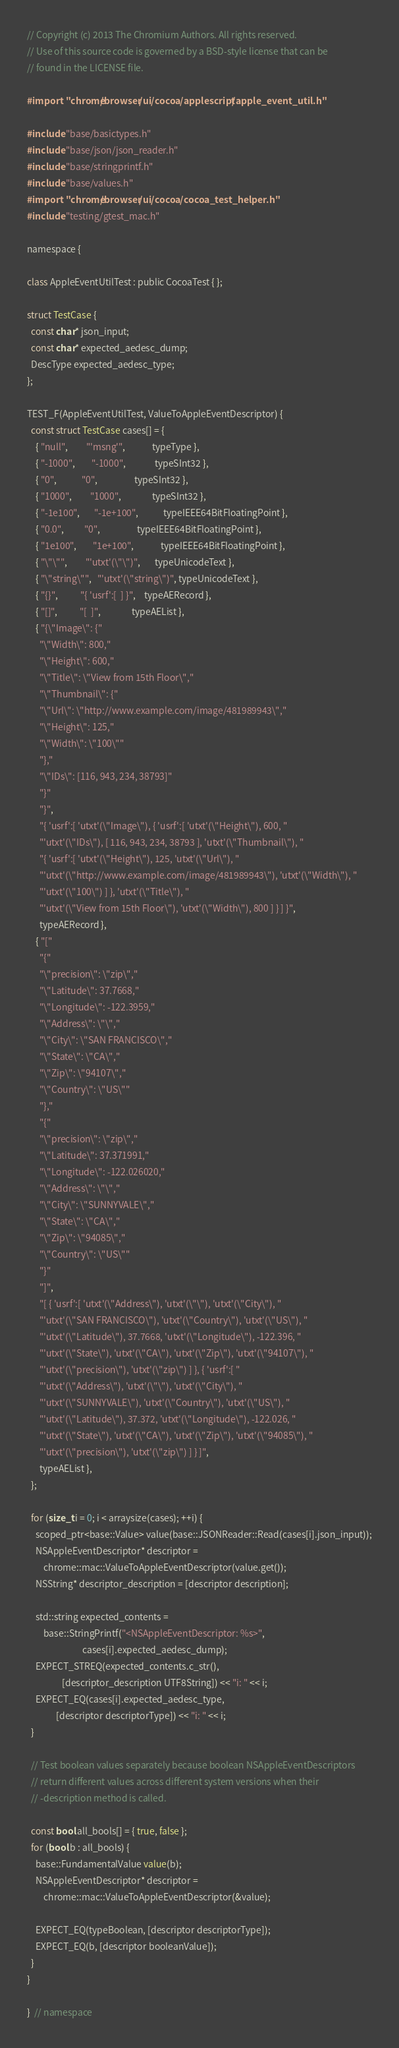<code> <loc_0><loc_0><loc_500><loc_500><_ObjectiveC_>// Copyright (c) 2013 The Chromium Authors. All rights reserved.
// Use of this source code is governed by a BSD-style license that can be
// found in the LICENSE file.

#import "chrome/browser/ui/cocoa/applescript/apple_event_util.h"

#include "base/basictypes.h"
#include "base/json/json_reader.h"
#include "base/stringprintf.h"
#include "base/values.h"
#import "chrome/browser/ui/cocoa/cocoa_test_helper.h"
#include "testing/gtest_mac.h"

namespace {

class AppleEventUtilTest : public CocoaTest { };

struct TestCase {
  const char* json_input;
  const char* expected_aedesc_dump;
  DescType expected_aedesc_type;
};

TEST_F(AppleEventUtilTest, ValueToAppleEventDescriptor) {
  const struct TestCase cases[] = {
    { "null",         "'msng'",             typeType },
    { "-1000",        "-1000",              typeSInt32 },
    { "0",            "0",                  typeSInt32 },
    { "1000",         "1000",               typeSInt32 },
    { "-1e100",       "-1e+100",            typeIEEE64BitFloatingPoint },
    { "0.0",          "0",                  typeIEEE64BitFloatingPoint },
    { "1e100",        "1e+100",             typeIEEE64BitFloatingPoint },
    { "\"\"",         "'utxt'(\"\")",       typeUnicodeText },
    { "\"string\"",   "'utxt'(\"string\")", typeUnicodeText },
    { "{}",           "{ 'usrf':[  ] }",    typeAERecord },
    { "[]",           "[  ]",               typeAEList },
    { "{\"Image\": {"
      "\"Width\": 800,"
      "\"Height\": 600,"
      "\"Title\": \"View from 15th Floor\","
      "\"Thumbnail\": {"
      "\"Url\": \"http://www.example.com/image/481989943\","
      "\"Height\": 125,"
      "\"Width\": \"100\""
      "},"
      "\"IDs\": [116, 943, 234, 38793]"
      "}"
      "}",
      "{ 'usrf':[ 'utxt'(\"Image\"), { 'usrf':[ 'utxt'(\"Height\"), 600, "
      "'utxt'(\"IDs\"), [ 116, 943, 234, 38793 ], 'utxt'(\"Thumbnail\"), "
      "{ 'usrf':[ 'utxt'(\"Height\"), 125, 'utxt'(\"Url\"), "
      "'utxt'(\"http://www.example.com/image/481989943\"), 'utxt'(\"Width\"), "
      "'utxt'(\"100\") ] }, 'utxt'(\"Title\"), "
      "'utxt'(\"View from 15th Floor\"), 'utxt'(\"Width\"), 800 ] } ] }",
      typeAERecord },
    { "["
      "{"
      "\"precision\": \"zip\","
      "\"Latitude\": 37.7668,"
      "\"Longitude\": -122.3959,"
      "\"Address\": \"\","
      "\"City\": \"SAN FRANCISCO\","
      "\"State\": \"CA\","
      "\"Zip\": \"94107\","
      "\"Country\": \"US\""
      "},"
      "{"
      "\"precision\": \"zip\","
      "\"Latitude\": 37.371991,"
      "\"Longitude\": -122.026020,"
      "\"Address\": \"\","
      "\"City\": \"SUNNYVALE\","
      "\"State\": \"CA\","
      "\"Zip\": \"94085\","
      "\"Country\": \"US\""
      "}"
      "]",
      "[ { 'usrf':[ 'utxt'(\"Address\"), 'utxt'(\"\"), 'utxt'(\"City\"), "
      "'utxt'(\"SAN FRANCISCO\"), 'utxt'(\"Country\"), 'utxt'(\"US\"), "
      "'utxt'(\"Latitude\"), 37.7668, 'utxt'(\"Longitude\"), -122.396, "
      "'utxt'(\"State\"), 'utxt'(\"CA\"), 'utxt'(\"Zip\"), 'utxt'(\"94107\"), "
      "'utxt'(\"precision\"), 'utxt'(\"zip\") ] }, { 'usrf':[ "
      "'utxt'(\"Address\"), 'utxt'(\"\"), 'utxt'(\"City\"), "
      "'utxt'(\"SUNNYVALE\"), 'utxt'(\"Country\"), 'utxt'(\"US\"), "
      "'utxt'(\"Latitude\"), 37.372, 'utxt'(\"Longitude\"), -122.026, "
      "'utxt'(\"State\"), 'utxt'(\"CA\"), 'utxt'(\"Zip\"), 'utxt'(\"94085\"), "
      "'utxt'(\"precision\"), 'utxt'(\"zip\") ] } ]",
      typeAEList },
  };

  for (size_t i = 0; i < arraysize(cases); ++i) {
    scoped_ptr<base::Value> value(base::JSONReader::Read(cases[i].json_input));
    NSAppleEventDescriptor* descriptor =
        chrome::mac::ValueToAppleEventDescriptor(value.get());
    NSString* descriptor_description = [descriptor description];

    std::string expected_contents =
        base::StringPrintf("<NSAppleEventDescriptor: %s>",
                           cases[i].expected_aedesc_dump);
    EXPECT_STREQ(expected_contents.c_str(),
                 [descriptor_description UTF8String]) << "i: " << i;
    EXPECT_EQ(cases[i].expected_aedesc_type,
              [descriptor descriptorType]) << "i: " << i;
  }

  // Test boolean values separately because boolean NSAppleEventDescriptors
  // return different values across different system versions when their
  // -description method is called.

  const bool all_bools[] = { true, false };
  for (bool b : all_bools) {
    base::FundamentalValue value(b);
    NSAppleEventDescriptor* descriptor =
        chrome::mac::ValueToAppleEventDescriptor(&value);

    EXPECT_EQ(typeBoolean, [descriptor descriptorType]);
    EXPECT_EQ(b, [descriptor booleanValue]);
  }
}

}  // namespace
</code> 